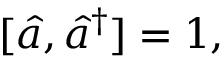<formula> <loc_0><loc_0><loc_500><loc_500>[ \hat { a } , \hat { a } ^ { \dagger } ] = 1 ,</formula> 